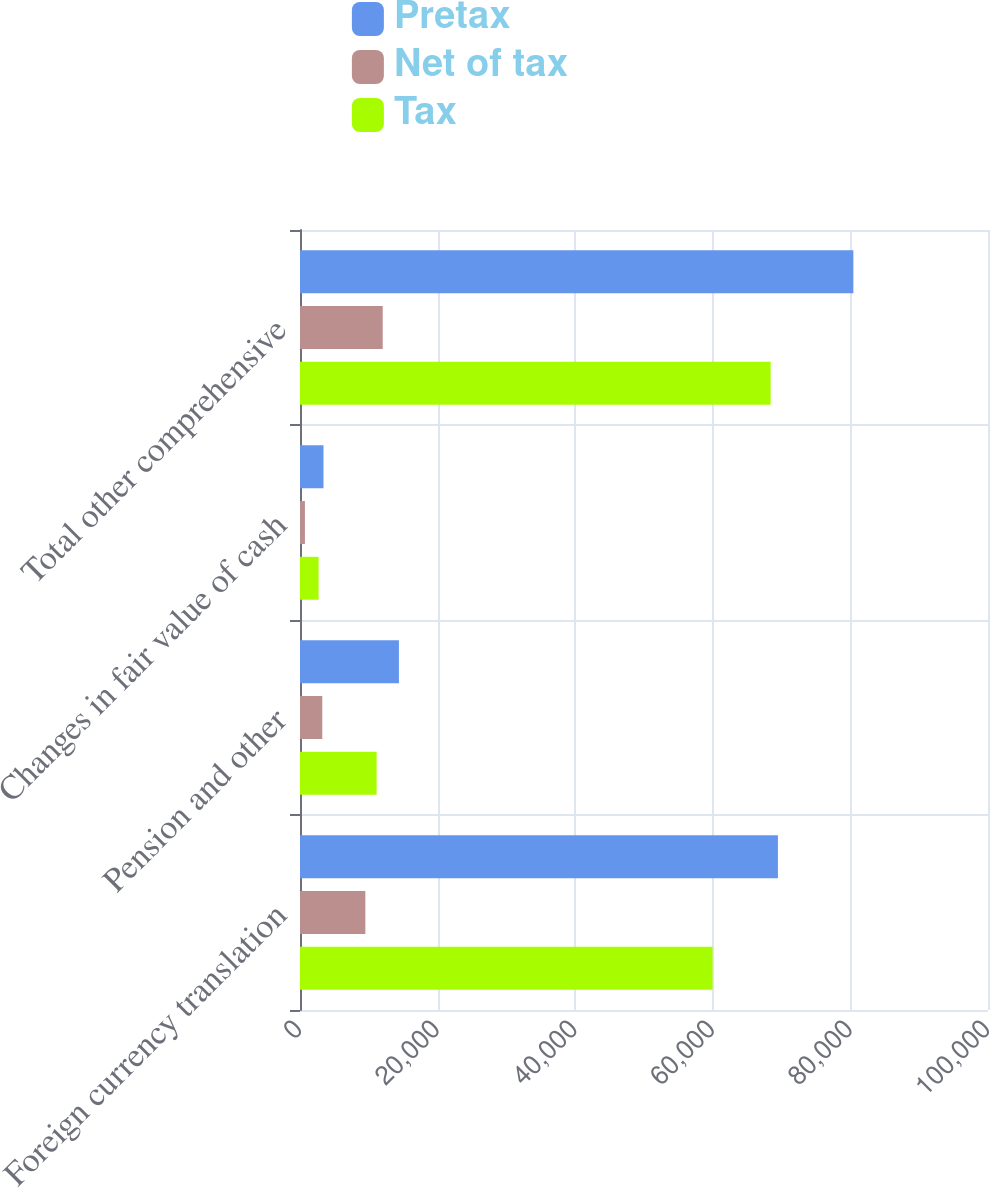<chart> <loc_0><loc_0><loc_500><loc_500><stacked_bar_chart><ecel><fcel>Foreign currency translation<fcel>Pension and other<fcel>Changes in fair value of cash<fcel>Total other comprehensive<nl><fcel>Pretax<fcel>69468<fcel>14379<fcel>3416<fcel>80431<nl><fcel>Net of tax<fcel>9498<fcel>3241<fcel>717<fcel>12022<nl><fcel>Tax<fcel>59970<fcel>11138<fcel>2699<fcel>68409<nl></chart> 